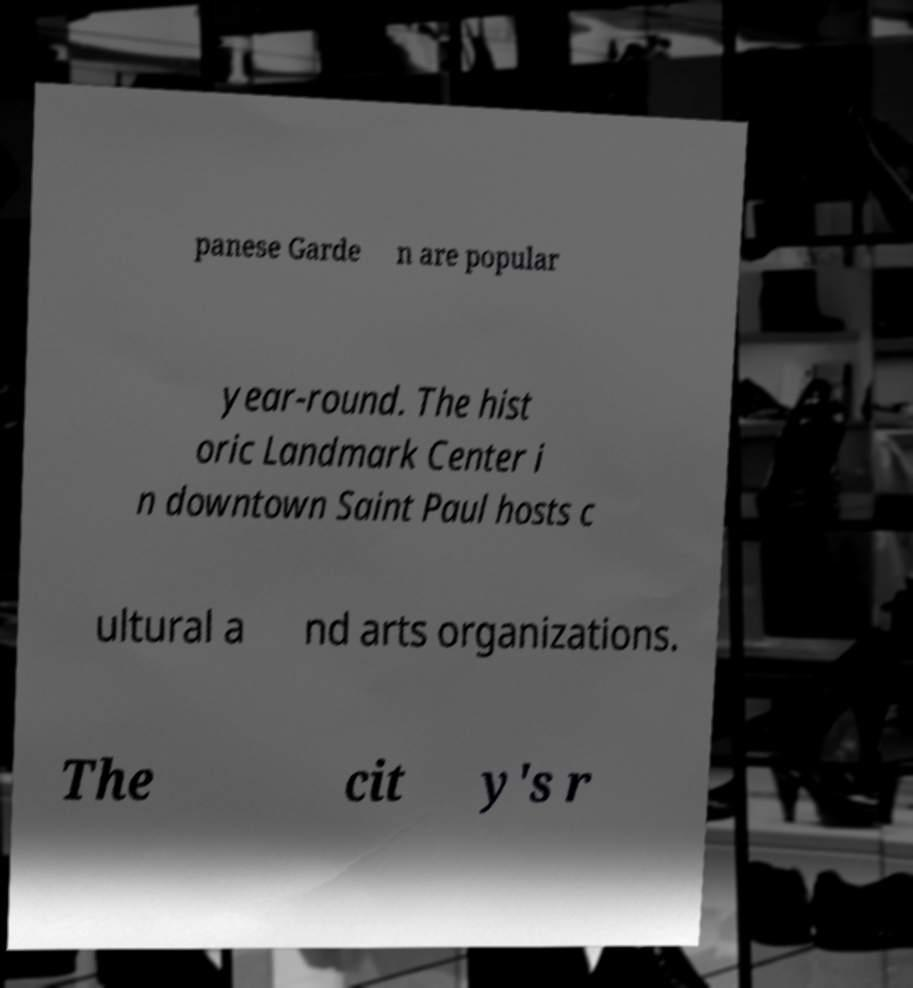Could you assist in decoding the text presented in this image and type it out clearly? panese Garde n are popular year-round. The hist oric Landmark Center i n downtown Saint Paul hosts c ultural a nd arts organizations. The cit y's r 